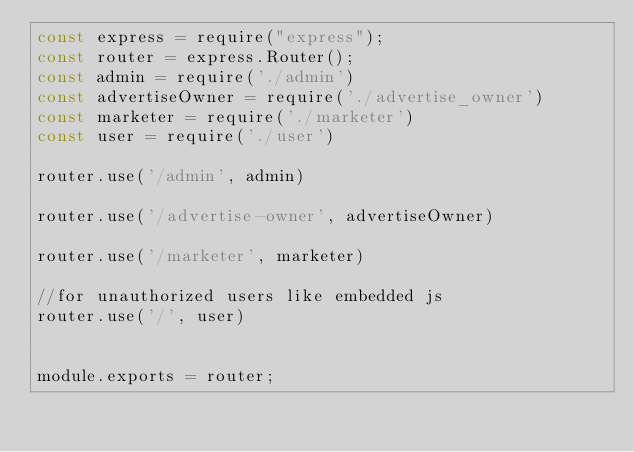Convert code to text. <code><loc_0><loc_0><loc_500><loc_500><_JavaScript_>const express = require("express");
const router = express.Router();
const admin = require('./admin')
const advertiseOwner = require('./advertise_owner')
const marketer = require('./marketer')
const user = require('./user')

router.use('/admin', admin)

router.use('/advertise-owner', advertiseOwner)

router.use('/marketer', marketer)

//for unauthorized users like embedded js
router.use('/', user)


module.exports = router;</code> 